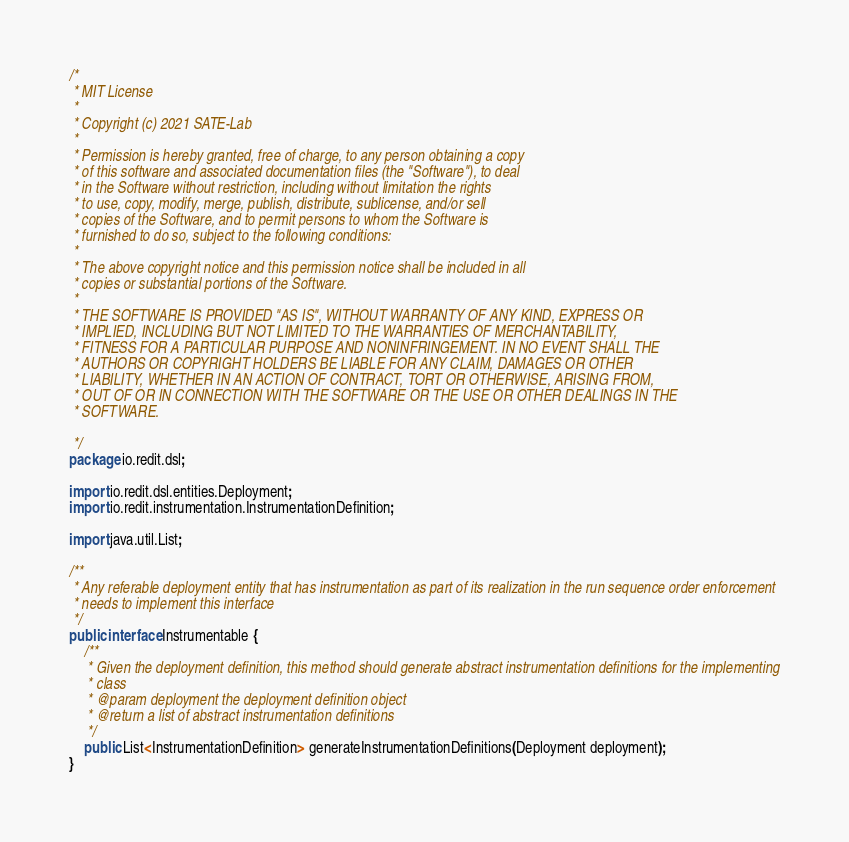Convert code to text. <code><loc_0><loc_0><loc_500><loc_500><_Java_>/*
 * MIT License
 *
 * Copyright (c) 2021 SATE-Lab
 *
 * Permission is hereby granted, free of charge, to any person obtaining a copy
 * of this software and associated documentation files (the "Software"), to deal
 * in the Software without restriction, including without limitation the rights
 * to use, copy, modify, merge, publish, distribute, sublicense, and/or sell
 * copies of the Software, and to permit persons to whom the Software is
 * furnished to do so, subject to the following conditions:
 *
 * The above copyright notice and this permission notice shall be included in all
 * copies or substantial portions of the Software.
 *
 * THE SOFTWARE IS PROVIDED "AS IS", WITHOUT WARRANTY OF ANY KIND, EXPRESS OR
 * IMPLIED, INCLUDING BUT NOT LIMITED TO THE WARRANTIES OF MERCHANTABILITY,
 * FITNESS FOR A PARTICULAR PURPOSE AND NONINFRINGEMENT. IN NO EVENT SHALL THE
 * AUTHORS OR COPYRIGHT HOLDERS BE LIABLE FOR ANY CLAIM, DAMAGES OR OTHER
 * LIABILITY, WHETHER IN AN ACTION OF CONTRACT, TORT OR OTHERWISE, ARISING FROM,
 * OUT OF OR IN CONNECTION WITH THE SOFTWARE OR THE USE OR OTHER DEALINGS IN THE
 * SOFTWARE.

 */
package io.redit.dsl;

import io.redit.dsl.entities.Deployment;
import io.redit.instrumentation.InstrumentationDefinition;

import java.util.List;

/**
 * Any referable deployment entity that has instrumentation as part of its realization in the run sequence order enforcement
 * needs to implement this interface
 */
public interface Instrumentable {
    /**
     * Given the deployment definition, this method should generate abstract instrumentation definitions for the implementing
     * class
     * @param deployment the deployment definition object
     * @return a list of abstract instrumentation definitions
     */
    public List<InstrumentationDefinition> generateInstrumentationDefinitions(Deployment deployment);
}
</code> 